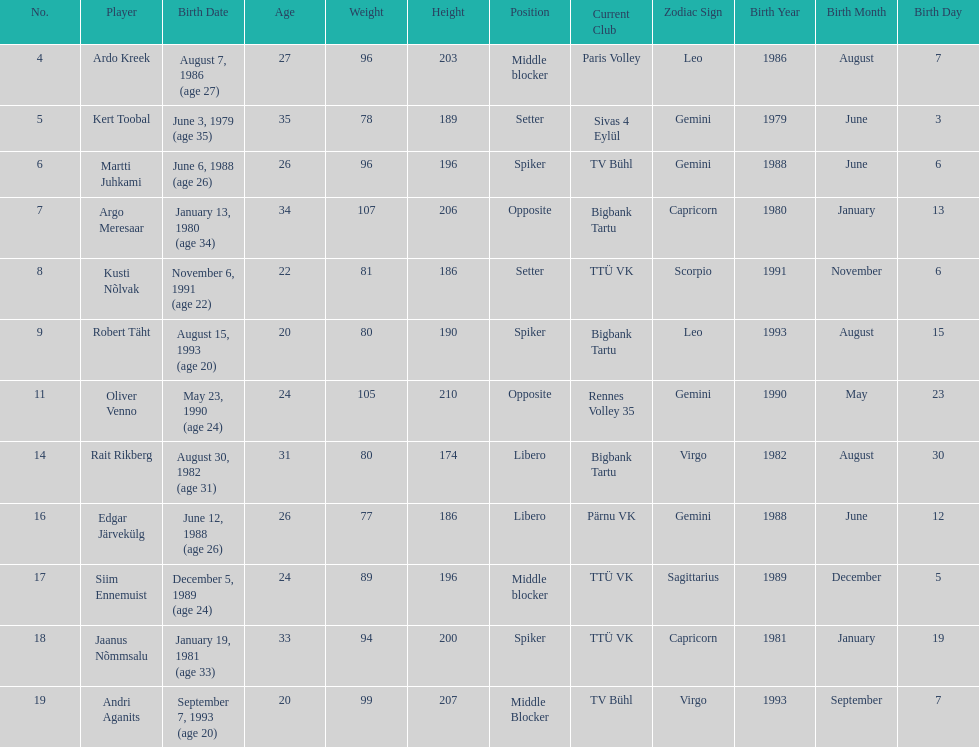Which player is taller than andri agantis? Oliver Venno. 